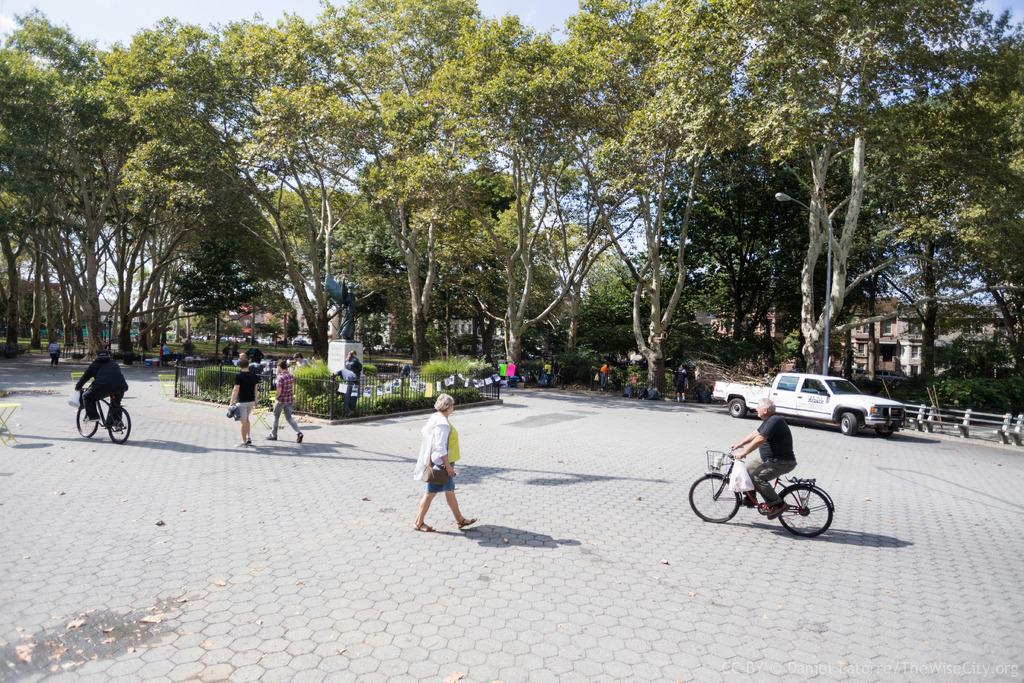Describe this image in one or two sentences. In this image I can see group of people, some are walking on the road and I can see two persons riding bicycle. Background I can see a vehicle in white color, a building in brown color, trees in green color and sky in white color. 